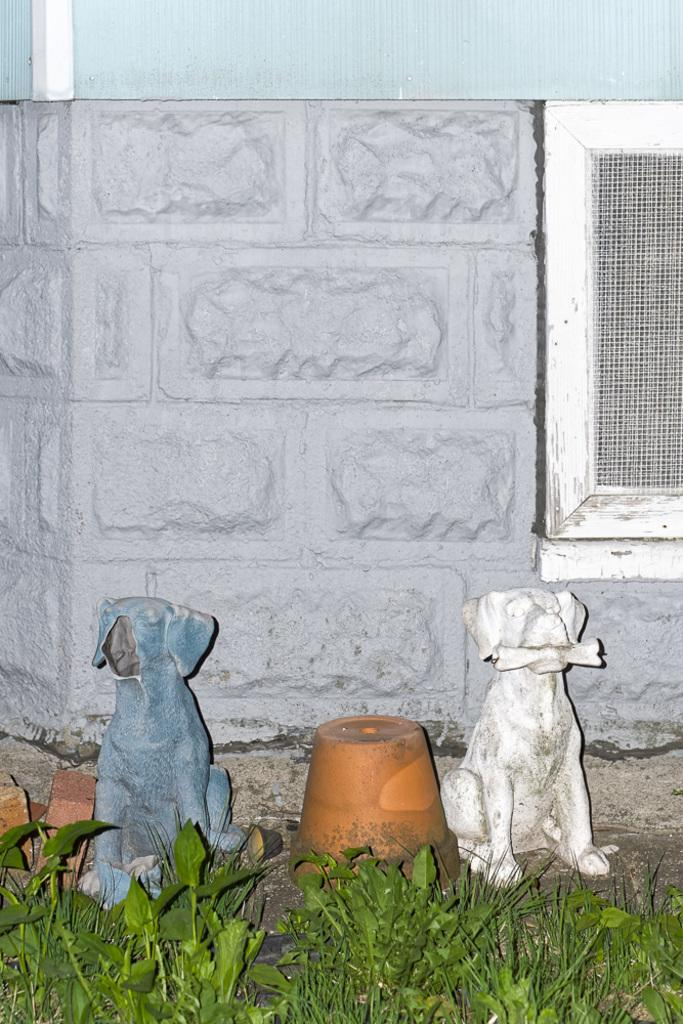What type of statues can be seen in the image? There are statues of dogs in the image. What object is present in the image that is typically used for holding or containing items? There is a pot in the image. What type of living organisms are visible in the image? There are plants in the image. What type of building material is present in the image? There are bricks in the image. What architectural feature can be seen on the backside of the image? There is a wall with a window on the backside of the image. What type of test can be seen being conducted in the image? There is no test being conducted in the image; it features statues of dogs, a pot, plants, bricks, and a wall with a window. What type of bottle is visible in the image? There is no bottle present in the image. 